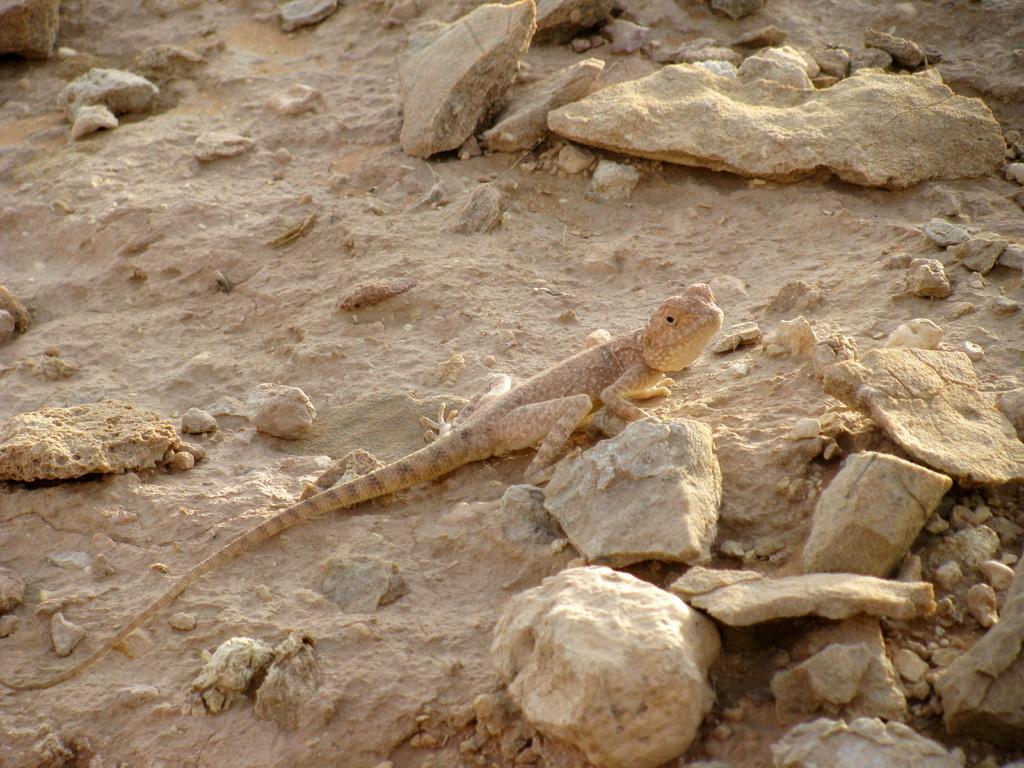Describe this image in one or two sentences. In this image we can see a lizard on the surface. We can also see some stones. 